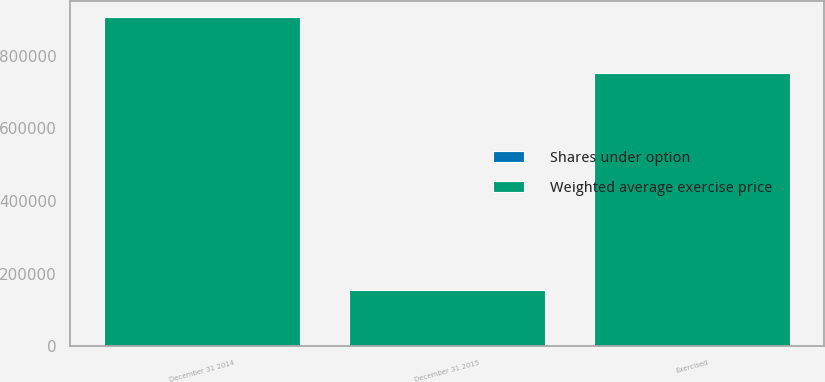Convert chart to OTSL. <chart><loc_0><loc_0><loc_500><loc_500><stacked_bar_chart><ecel><fcel>December 31 2014<fcel>Exercised<fcel>December 31 2015<nl><fcel>Weighted average exercise price<fcel>906719<fcel>752625<fcel>154094<nl><fcel>Shares under option<fcel>167.76<fcel>167.76<fcel>167.76<nl></chart> 